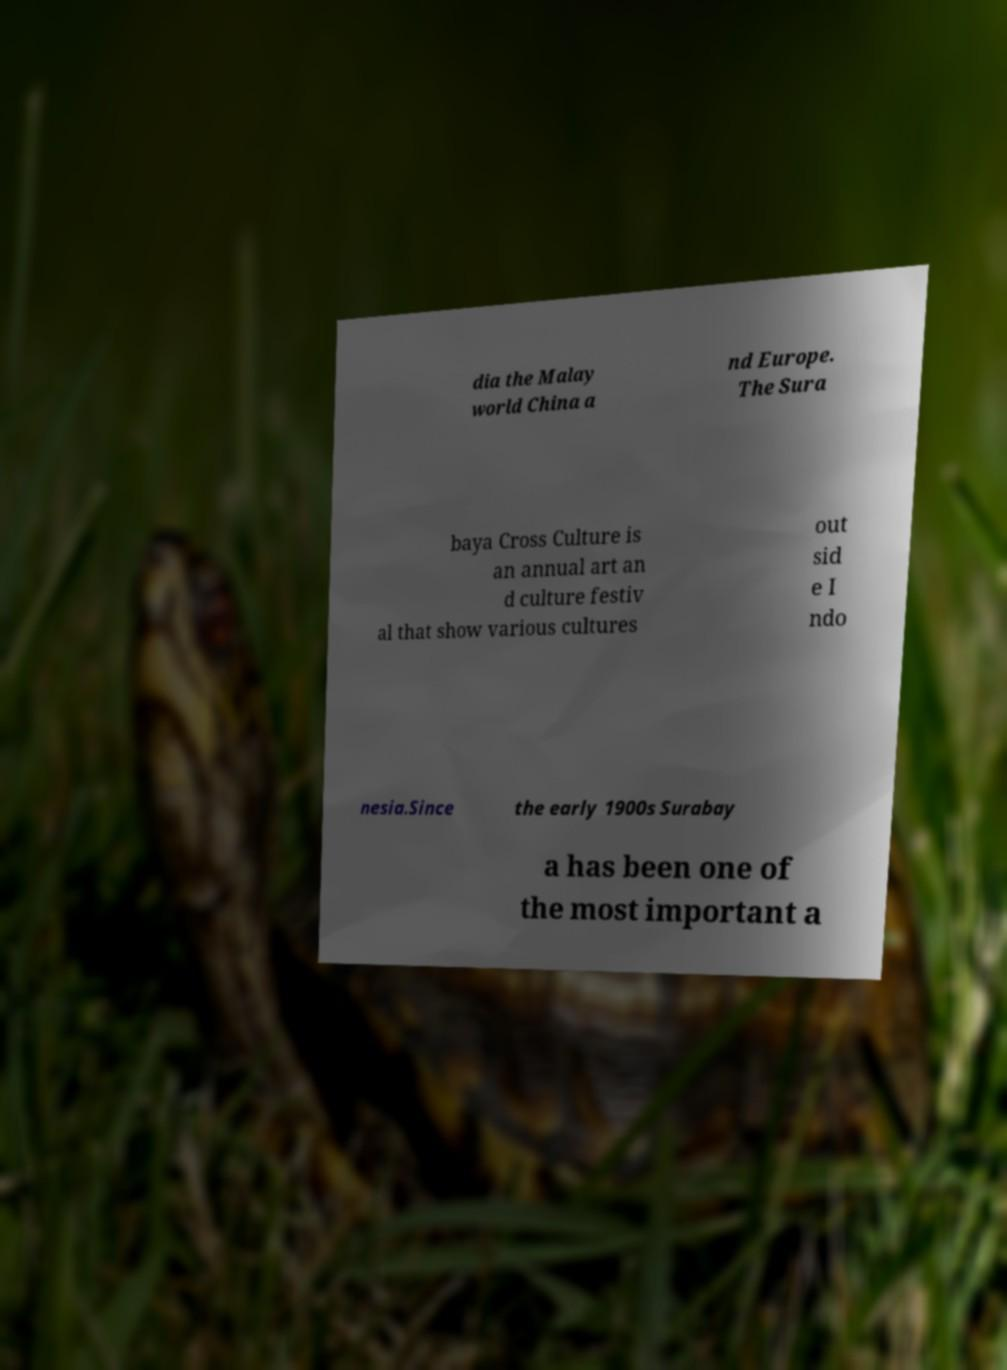For documentation purposes, I need the text within this image transcribed. Could you provide that? dia the Malay world China a nd Europe. The Sura baya Cross Culture is an annual art an d culture festiv al that show various cultures out sid e I ndo nesia.Since the early 1900s Surabay a has been one of the most important a 